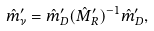<formula> <loc_0><loc_0><loc_500><loc_500>\hat { m } _ { \nu } ^ { \prime } = \hat { m } _ { D } ^ { \prime } ( \hat { M } _ { R } ^ { \prime } ) ^ { - 1 } \hat { m } _ { D } ^ { \prime } ,</formula> 